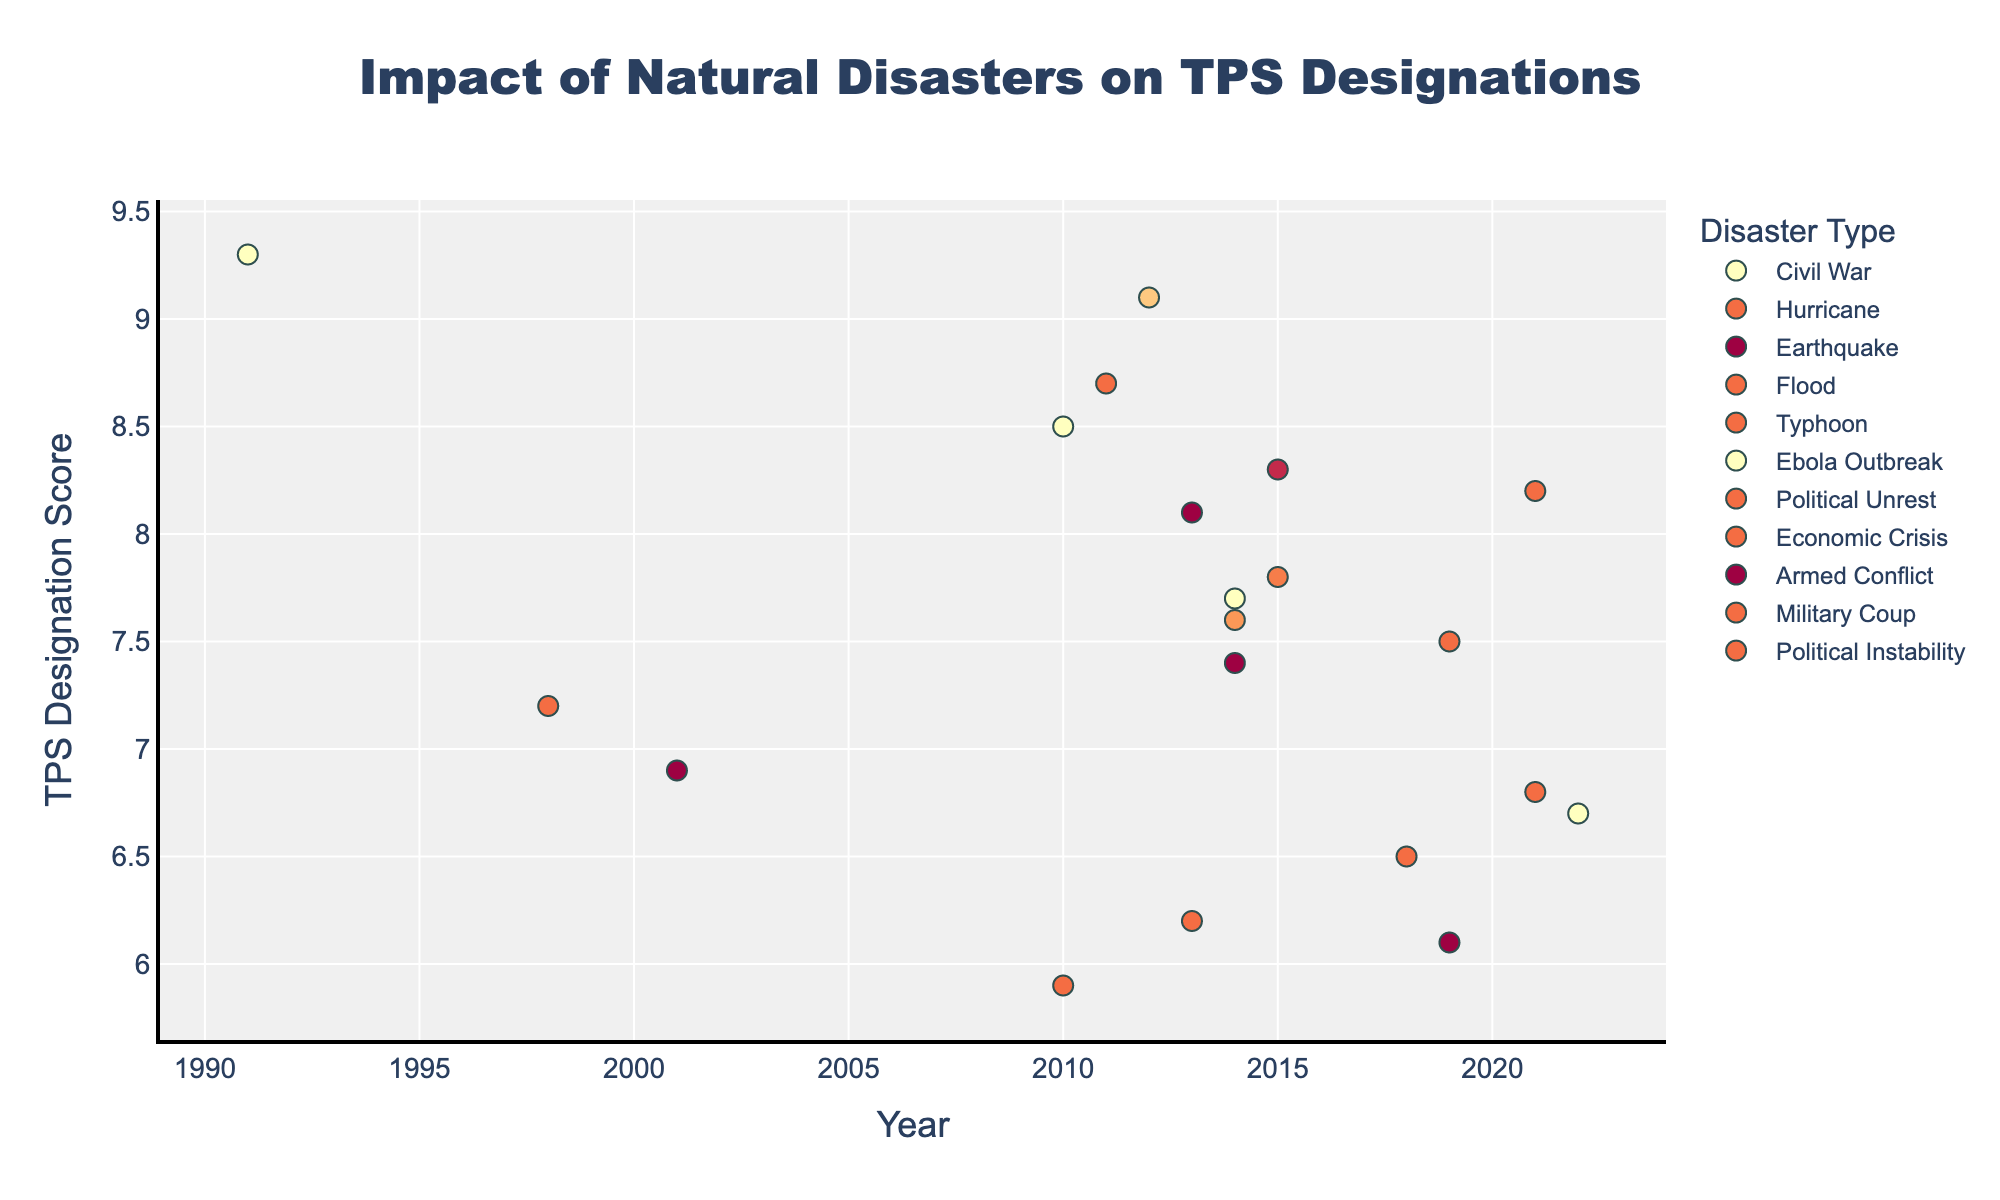What's the highest TPS Designation Score recorded and which country does it correspond to? To find the highest score, look for the data point with the highest y-value on the plot. From the data, the highest score is 9.3 and corresponds to Somalia in 1991 due to a Civil War.
Answer: 9.3, Somalia Which year saw the most diverse types of disasters leading to TPS designations? Check the x-axis to see which year has the most different colored markers, indicative of different disaster types. Year 2015 shows multiple types, including Earthquake (Nepal) and Civil War (Yemen).
Answer: 2015 Which disaster type has the highest average TPS Designation Score? Calculate the average score for each disaster type by summing their scores and dividing by the number of instances. Civil War has a high average score due to high individual scores (e.g., Syria 9.1, South Sudan 8.7).
Answer: Civil War How many countries had TPS Designations due to Ebola Outbreak in 2014 and what were their scores? Identify the markers from 2014 related to the Ebola Outbreak through their labels and shapes. There are three such countries: Sierra Leone (7.7), Liberia (7.6), and Guinea (7.4).
Answer: 3; 7.7, 7.6, 7.4 Which country had the TPS Designation Score closest to the midpoint between the highest and lowest scores in the dataset? The highest score is 9.3 (Somalia) and the lowest is 5.9 (Pakistan), making the midpoint (9.3 + 5.9) / 2 = 7.6. Liberia in 2014 due to Ebola Outbreak has a score of 7.6.
Answer: Liberia Are there more TPS designations resulting from Earthquakes or Armed Conflicts? Count the number of data points labeled as earthquakes and those labeled as armed conflicts by identifying respective markers. Earthquakes: Haiti (2010), El Salvador (2001), Nepal (2015) — 3 occurrences. Armed Conflicts: Ethiopia (2022), Cameroon (2019) — 2 occurrences.
Answer: Earthquakes Which year had the highest cumulative TPS Designation Score? Sum the scores of all data points within each year and compare to find the highest. For instance, 2015 has multiple high scores: Nepal (7.8) and Yemen (8.3), summing to 16.1.
Answer: 2015 Between Economic Crisis (Venezuela) and Military Coup (Myanmar), which had the higher TPS Designation Score? Compare the single data points for Venezuela (2019, Economic Crisis, 7.5) and Myanmar (2021, Military Coup, 6.8). Venezuela's score is higher.
Answer: Economic Crisis (Venezuela) 